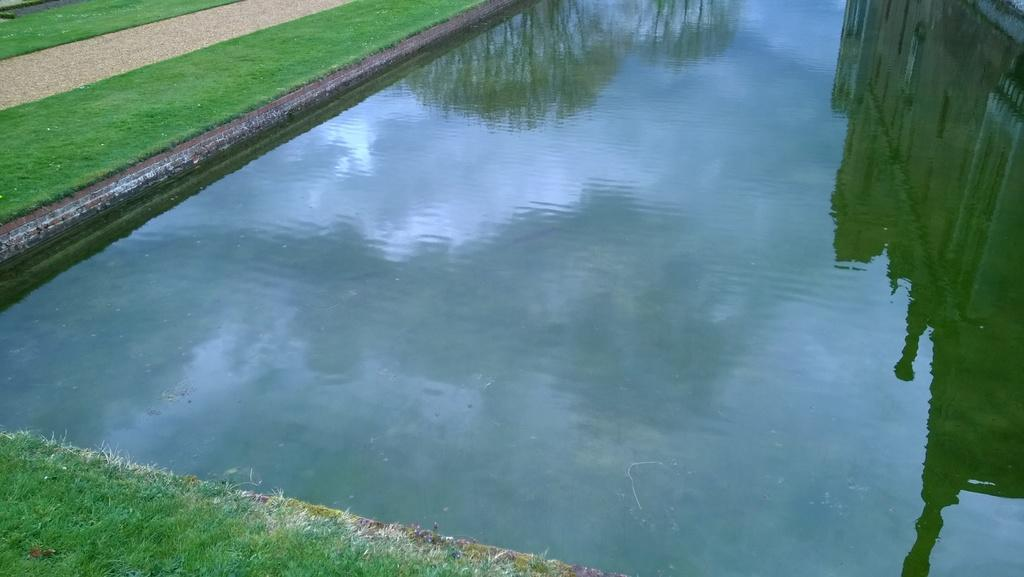What type of surface can be seen on the ground in the image? The ground with grass is visible in the image. What natural element is present in the image? There is water in the image. What effect can be observed on the water's surface? Reflections are present on the water's surface. What type of car is visible in the image? There is no car present in the image. Can you tell me how many zippers are on the grass in the image? There are no zippers present in the image, as zippers are not associated with grass. 